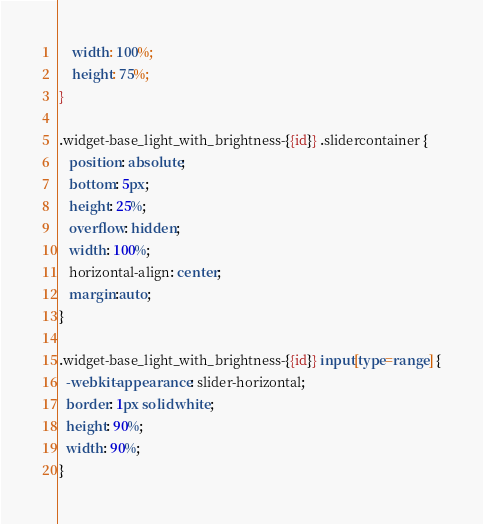Convert code to text. <code><loc_0><loc_0><loc_500><loc_500><_CSS_>	width: 100%;
	height: 75%;
}

.widget-base_light_with_brightness-{{id}} .slidercontainer {
   position: absolute;
   bottom: 5px;
   height: 25%;
   overflow: hidden;
   width: 100%;
   horizontal-align: center;
   margin:auto;
}

.widget-base_light_with_brightness-{{id}} input[type=range] {
  -webkit-appearance: slider-horizontal;
  border: 1px solid white;
  height: 90%;
  width: 90%;
}
</code> 